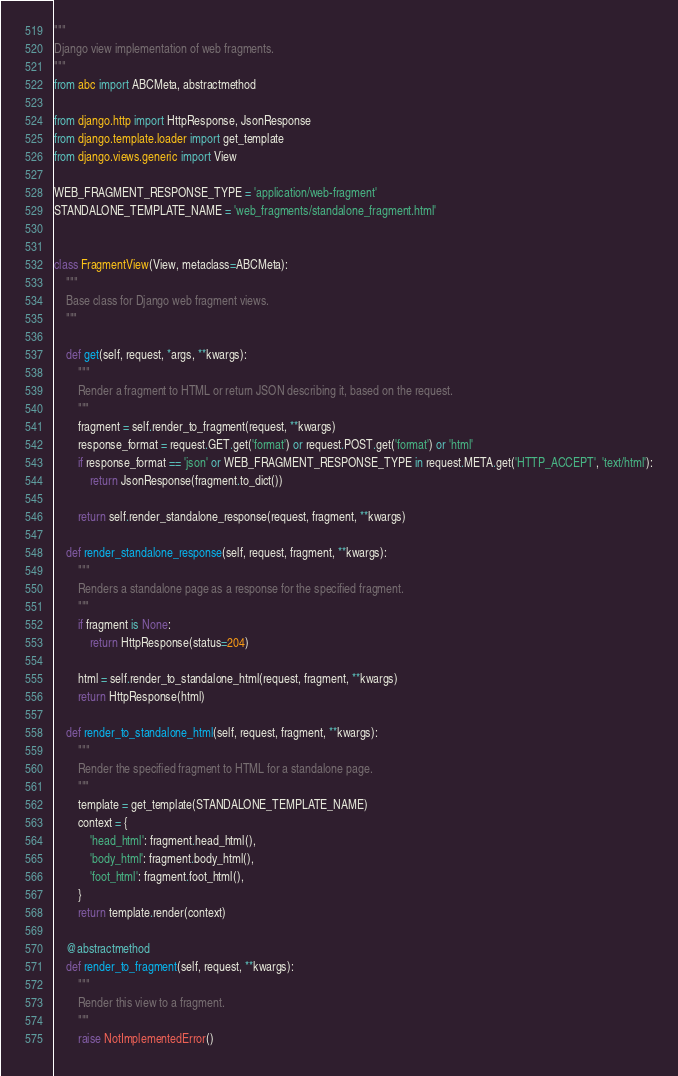<code> <loc_0><loc_0><loc_500><loc_500><_Python_>"""
Django view implementation of web fragments.
"""
from abc import ABCMeta, abstractmethod

from django.http import HttpResponse, JsonResponse
from django.template.loader import get_template
from django.views.generic import View

WEB_FRAGMENT_RESPONSE_TYPE = 'application/web-fragment'
STANDALONE_TEMPLATE_NAME = 'web_fragments/standalone_fragment.html'


class FragmentView(View, metaclass=ABCMeta):
    """
    Base class for Django web fragment views.
    """

    def get(self, request, *args, **kwargs):
        """
        Render a fragment to HTML or return JSON describing it, based on the request.
        """
        fragment = self.render_to_fragment(request, **kwargs)
        response_format = request.GET.get('format') or request.POST.get('format') or 'html'
        if response_format == 'json' or WEB_FRAGMENT_RESPONSE_TYPE in request.META.get('HTTP_ACCEPT', 'text/html'):
            return JsonResponse(fragment.to_dict())

        return self.render_standalone_response(request, fragment, **kwargs)

    def render_standalone_response(self, request, fragment, **kwargs):
        """
        Renders a standalone page as a response for the specified fragment.
        """
        if fragment is None:
            return HttpResponse(status=204)

        html = self.render_to_standalone_html(request, fragment, **kwargs)
        return HttpResponse(html)

    def render_to_standalone_html(self, request, fragment, **kwargs):
        """
        Render the specified fragment to HTML for a standalone page.
        """
        template = get_template(STANDALONE_TEMPLATE_NAME)
        context = {
            'head_html': fragment.head_html(),
            'body_html': fragment.body_html(),
            'foot_html': fragment.foot_html(),
        }
        return template.render(context)

    @abstractmethod
    def render_to_fragment(self, request, **kwargs):
        """
        Render this view to a fragment.
        """
        raise NotImplementedError()
</code> 